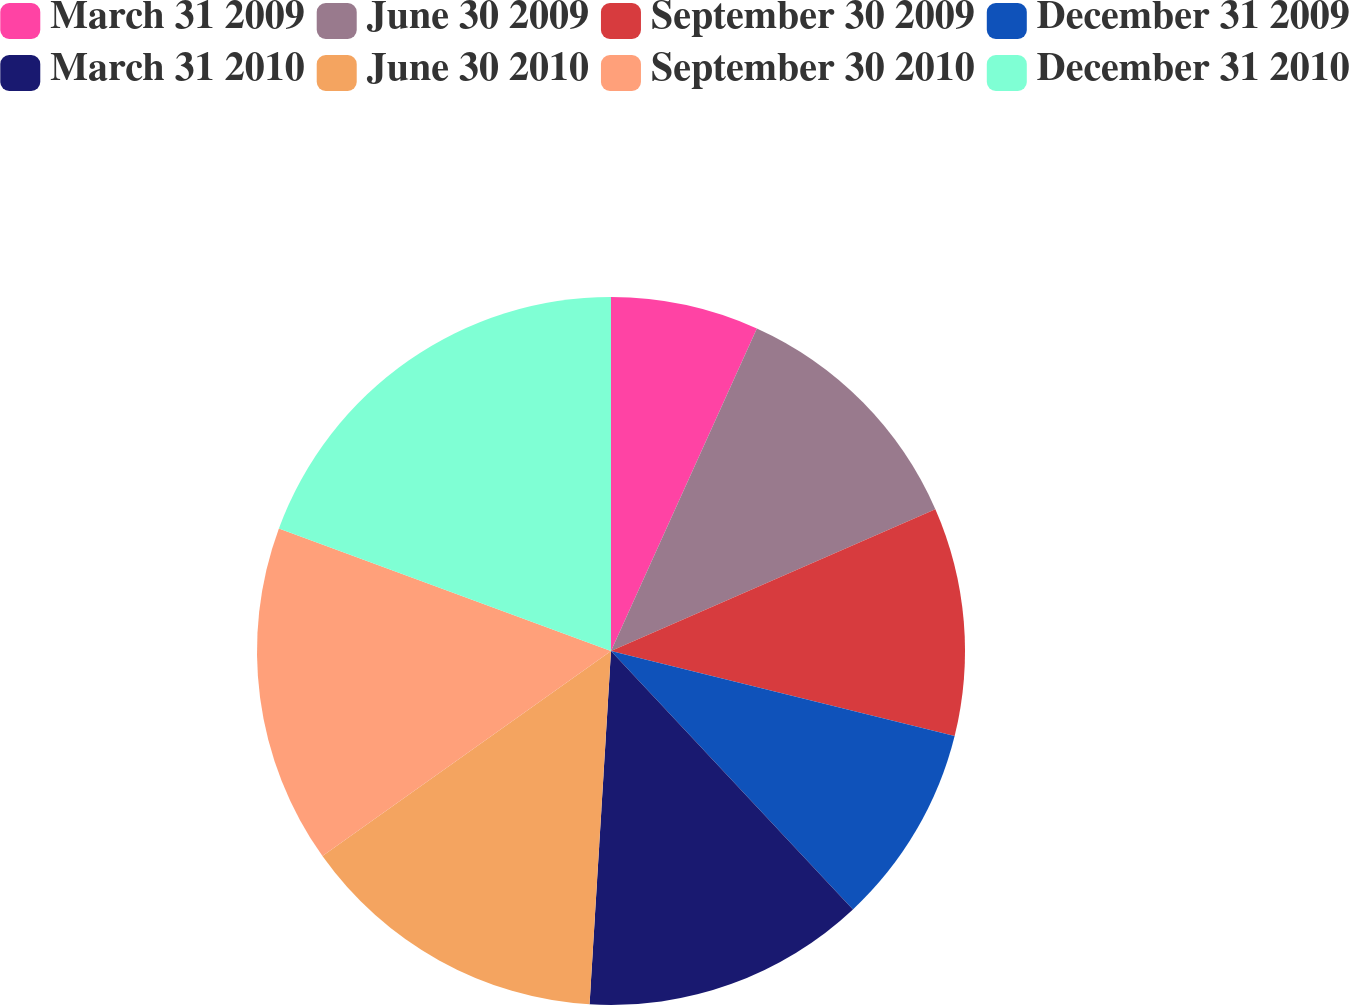Convert chart to OTSL. <chart><loc_0><loc_0><loc_500><loc_500><pie_chart><fcel>March 31 2009<fcel>June 30 2009<fcel>September 30 2009<fcel>December 31 2009<fcel>March 31 2010<fcel>June 30 2010<fcel>September 30 2010<fcel>December 31 2010<nl><fcel>6.76%<fcel>11.68%<fcel>10.42%<fcel>9.16%<fcel>12.94%<fcel>14.2%<fcel>15.46%<fcel>19.37%<nl></chart> 